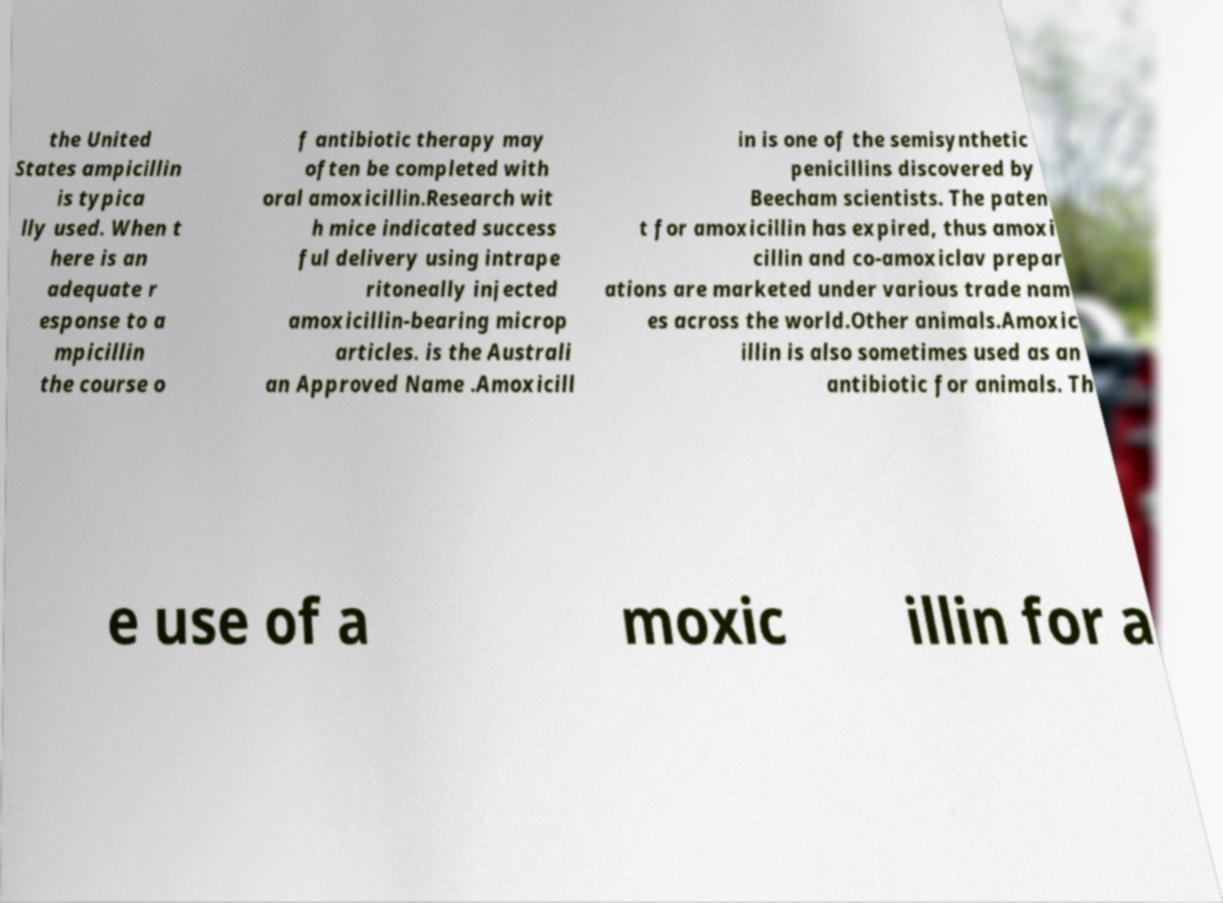What messages or text are displayed in this image? I need them in a readable, typed format. the United States ampicillin is typica lly used. When t here is an adequate r esponse to a mpicillin the course o f antibiotic therapy may often be completed with oral amoxicillin.Research wit h mice indicated success ful delivery using intrape ritoneally injected amoxicillin-bearing microp articles. is the Australi an Approved Name .Amoxicill in is one of the semisynthetic penicillins discovered by Beecham scientists. The paten t for amoxicillin has expired, thus amoxi cillin and co-amoxiclav prepar ations are marketed under various trade nam es across the world.Other animals.Amoxic illin is also sometimes used as an antibiotic for animals. Th e use of a moxic illin for a 